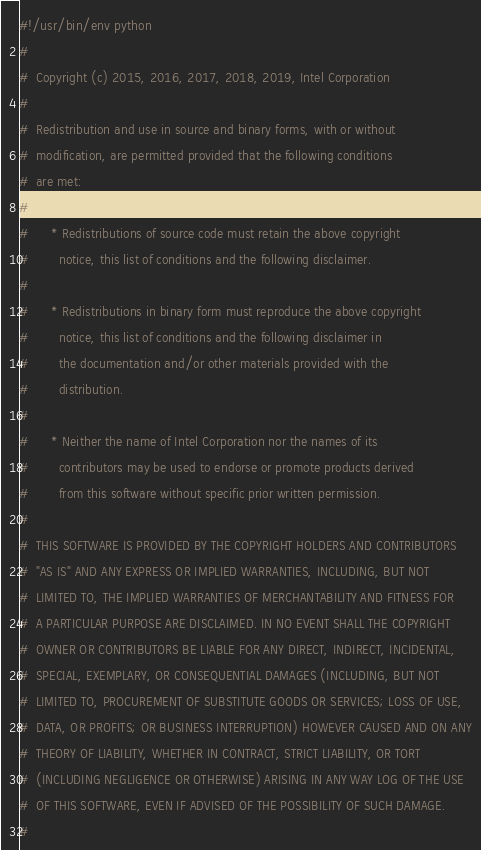Convert code to text. <code><loc_0><loc_0><loc_500><loc_500><_Python_>#!/usr/bin/env python
#
#  Copyright (c) 2015, 2016, 2017, 2018, 2019, Intel Corporation
#
#  Redistribution and use in source and binary forms, with or without
#  modification, are permitted provided that the following conditions
#  are met:
#
#      * Redistributions of source code must retain the above copyright
#        notice, this list of conditions and the following disclaimer.
#
#      * Redistributions in binary form must reproduce the above copyright
#        notice, this list of conditions and the following disclaimer in
#        the documentation and/or other materials provided with the
#        distribution.
#
#      * Neither the name of Intel Corporation nor the names of its
#        contributors may be used to endorse or promote products derived
#        from this software without specific prior written permission.
#
#  THIS SOFTWARE IS PROVIDED BY THE COPYRIGHT HOLDERS AND CONTRIBUTORS
#  "AS IS" AND ANY EXPRESS OR IMPLIED WARRANTIES, INCLUDING, BUT NOT
#  LIMITED TO, THE IMPLIED WARRANTIES OF MERCHANTABILITY AND FITNESS FOR
#  A PARTICULAR PURPOSE ARE DISCLAIMED. IN NO EVENT SHALL THE COPYRIGHT
#  OWNER OR CONTRIBUTORS BE LIABLE FOR ANY DIRECT, INDIRECT, INCIDENTAL,
#  SPECIAL, EXEMPLARY, OR CONSEQUENTIAL DAMAGES (INCLUDING, BUT NOT
#  LIMITED TO, PROCUREMENT OF SUBSTITUTE GOODS OR SERVICES; LOSS OF USE,
#  DATA, OR PROFITS; OR BUSINESS INTERRUPTION) HOWEVER CAUSED AND ON ANY
#  THEORY OF LIABILITY, WHETHER IN CONTRACT, STRICT LIABILITY, OR TORT
#  (INCLUDING NEGLIGENCE OR OTHERWISE) ARISING IN ANY WAY LOG OF THE USE
#  OF THIS SOFTWARE, EVEN IF ADVISED OF THE POSSIBILITY OF SUCH DAMAGE.
#
</code> 